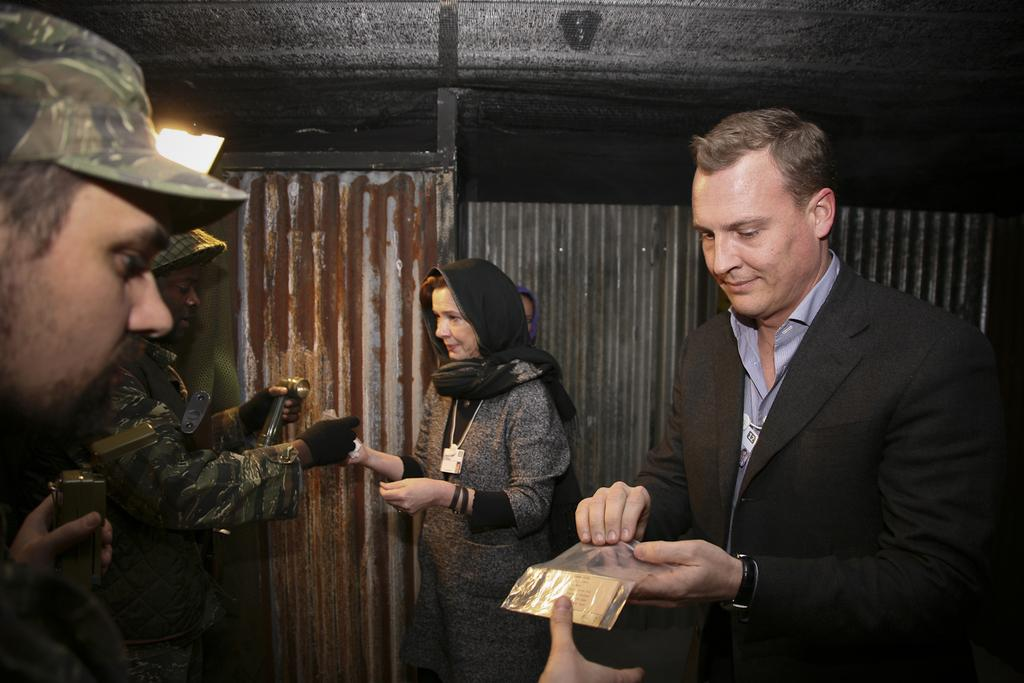How many people are in the image? There is a group of people in the image, but the exact number is not specified. What are the people doing in the image? The people are holding objects, but the nature of these objects is not mentioned. What is the name of the town where the people are gathering in the image? There is no town present in the image, and the location of the gathering is not specified. 